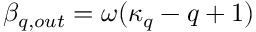Convert formula to latex. <formula><loc_0><loc_0><loc_500><loc_500>\beta _ { q , o u t } = \omega ( \kappa _ { q } - q + 1 )</formula> 